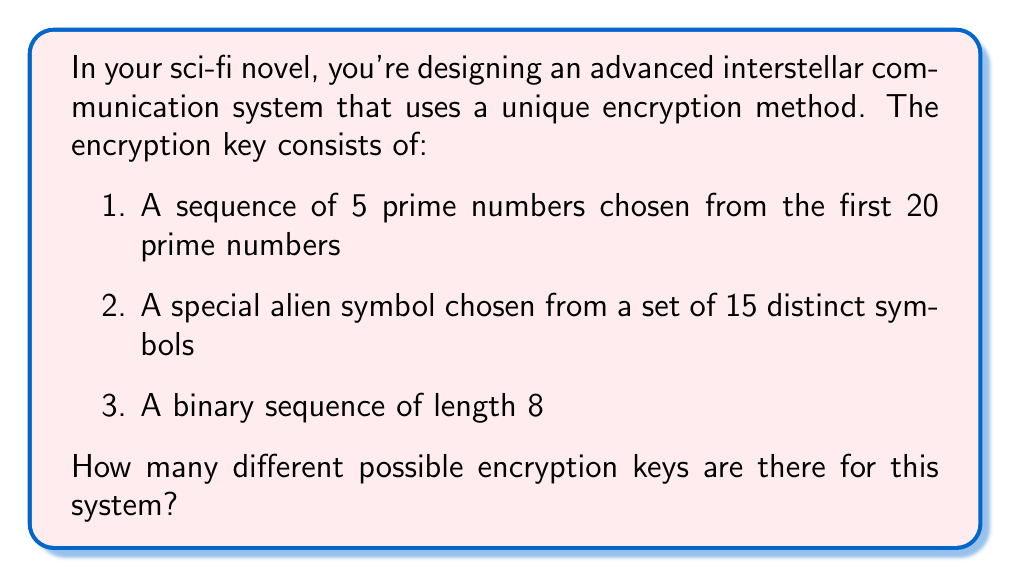Can you solve this math problem? Let's break this down step by step:

1. First, let's count the prime numbers up to 71 (the 20th prime):
   2, 3, 5, 7, 11, 13, 17, 19, 23, 29, 31, 37, 41, 43, 47, 53, 59, 61, 67, 71

   We need to choose 5 from these 20 primes. This is a combination problem, represented as $\binom{20}{5}$. 
   
   $$\binom{20}{5} = \frac{20!}{5!(20-5)!} = \frac{20!}{5!15!} = 15504$$

2. For the alien symbol, we simply have 15 choices.

3. For the binary sequence of length 8, we have 2 choices (0 or 1) for each of the 8 positions. This gives us $2^8 = 256$ possibilities.

Now, according to the multiplication principle, if we have independent choices, we multiply the number of possibilities for each choice. Therefore, the total number of possible encryption keys is:

$$15504 \times 15 \times 256 = 59,535,360$$
Answer: 59,535,360 